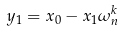<formula> <loc_0><loc_0><loc_500><loc_500>y _ { 1 } = x _ { 0 } - x _ { 1 } \omega _ { n } ^ { k }</formula> 